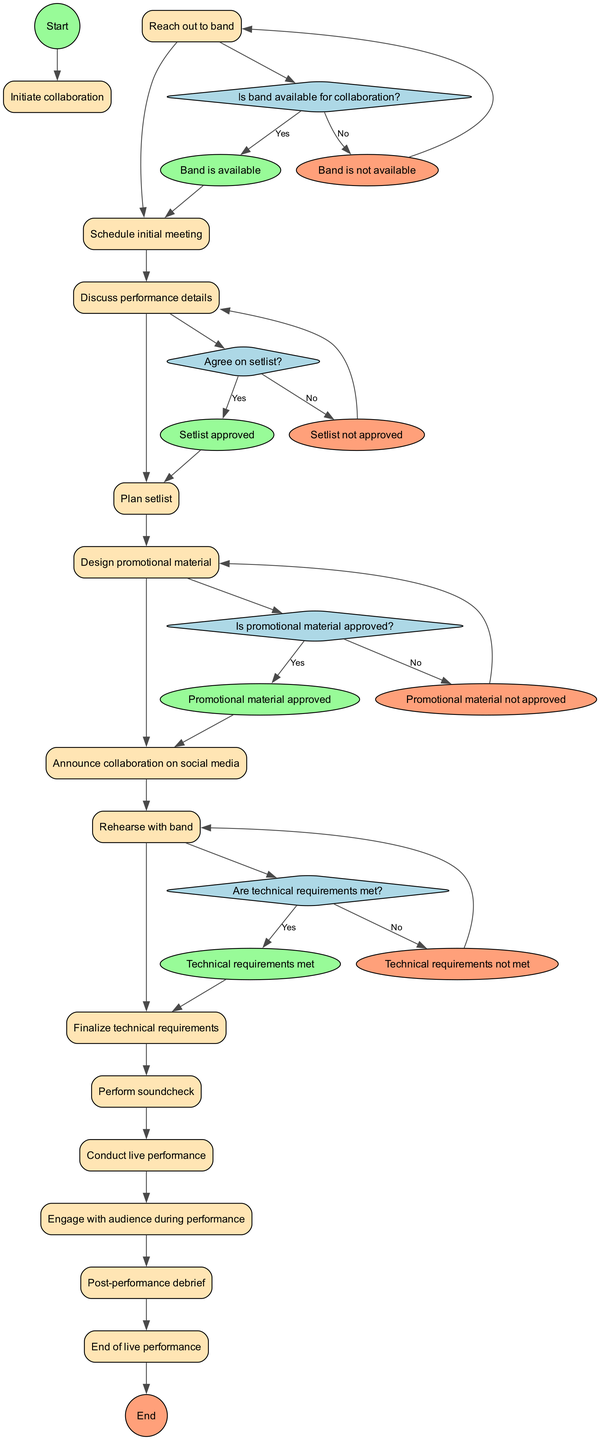What is the first activity in the diagram? The first activity is represented as "Reach out to band" following the start node. Since activity nodes flow from the start, it is the first listed item in the activities section.
Answer: Reach out to band How many activities are shown in the diagram? There are 11 activities listed, and all of them can be counted as separate nodes between the start and end nodes.
Answer: 11 What is the last activity before the end of the diagram? The last activity is "Post-performance debrief," which is the final step before transitioning to the end node.
Answer: Post-performance debrief What decision occurs after discussing performance details? After discussing performance details, the decision is "Agree on setlist?", which indicates a choice that must be made regarding the approved setlist.
Answer: Agree on setlist? Which decision corresponds to the event "Technical requirements met"? The decision that corresponds to "Technical requirements met" is "Are technical requirements met?" This indicates the question that checks if the technical needs have been fulfilled before proceeding.
Answer: Are technical requirements met? What is the event if the promotional material is not approved? If the promotional material is not approved, the event that results is "Promotional material not approved," proceeding from the related decision node.
Answer: Promotional material not approved How many decision nodes are present in the diagram? There are four decision nodes shown in the diagram, each representing a crucial point where a choice affects the flow of activities.
Answer: 4 At what point does rehearsal with the band occur? Rehearsal with the band occurs after the decision "Is promotional material approved?" and the corresponding event "Promotional material approved," indicating that all preparations are on track.
Answer: After promotional material approved What color represents the events in the diagram? The events are represented in an ellipse shape filled with the color '#98FB98' for positive outcomes and '#FFA07A' for negative outcomes throughout the diagram.
Answer: #98FB98 and #FFA07A 